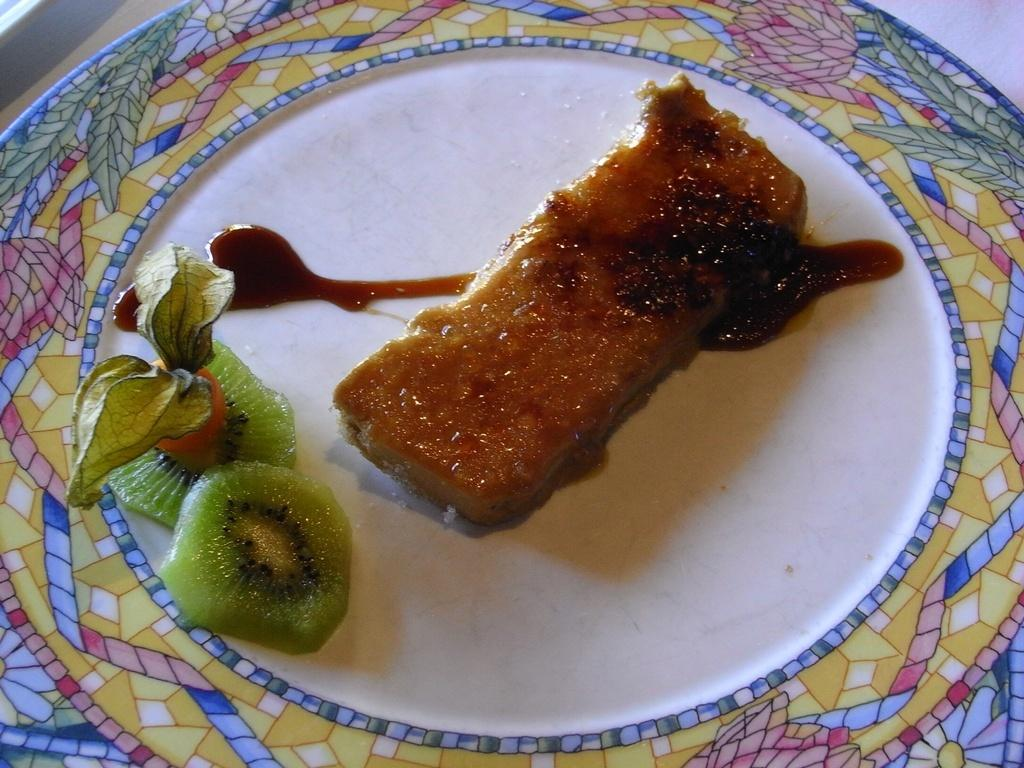What type of food item can be seen in the image? There is a food item in the image, but the specific type is not mentioned in the facts. What is the cream used for in the image? The cream is used as a topping or ingredient for the food item in the image. What type of fruit is present in the image? The fruit slices in the image are not specified, so we cannot determine the type of fruit. What is the purpose of the leaves in the image? The leaves in the image are likely used as a garnish or decoration for the food item. What is the food item placed on in the image? The food item is placed on a plate in the image. What is the platform used for in the image? The platform in the image is likely used to elevate or display the food item. What organization is responsible for the stitching of the fruit slices in the image? There is no stitching or organization mentioned in the image; the fruit slices are simply placed on the food item. 